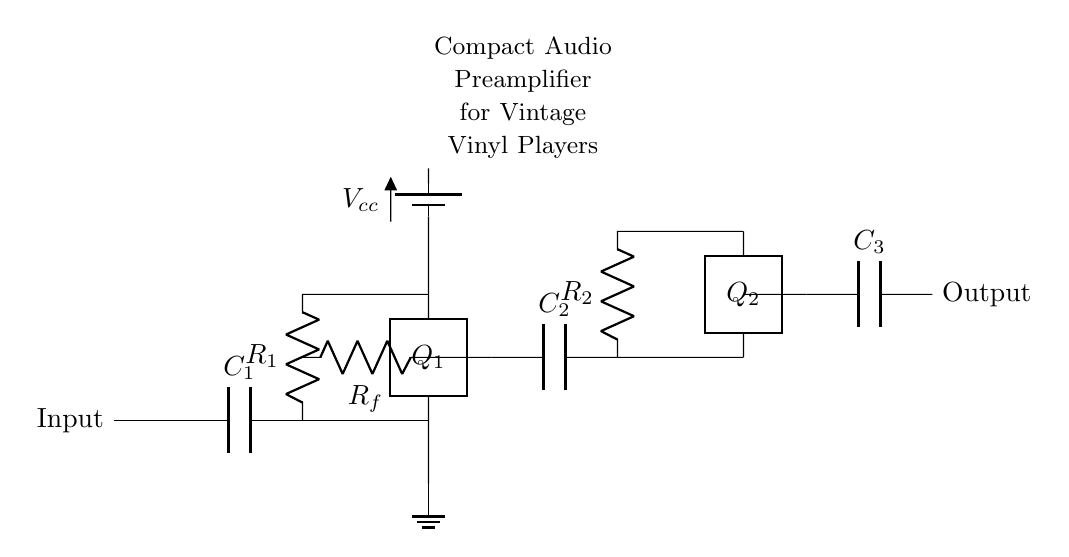What is the input component in this circuit? The input component is a capacitor, labeled as C1. It functions to couple the audio signal from the vinyl record player into the circuit while blocking any DC components.
Answer: C1 What type of transistors are used in this circuit? The circuit utilizes two bipolar junction transistors, indicated as Q1 and Q2, which amplify the audio signal.
Answer: Bipolar junction transistors How are the feedback and the input connected in the first stage? The feedback resistor Rf connects from the output side of the first transistor Q1 back to the input side, specifically between point (5,1) and (3,1), thereby providing negative feedback to stabilize the gain of the amplifier.
Answer: Through a feedback resistor What is the total number of capacitors in this circuit? Three capacitors are present in the circuit, C1 at the input, C2 in the second stage, and C3 at the output.
Answer: Three What is the purpose of the Rf component in this circuit? The resistor Rf is used to provide feedback to the first transistor Q1, which helps control the gain of the amplifier and stabilize the circuit operation by reducing distortion.
Answer: Control gain What voltage does the power supply provide? The power supply, labeled Vcc, provides a voltage that powers the circuit and is located at the battery section above transistor Q1, which usually needs to be set according to the specifications of the transistors used.
Answer: Vcc (not specified in value) How many stages of amplification are present in this preamplifier circuit? The circuit has two stages of amplification, with Q1 and Q2 representing the first and second stages respectively, allowing for increased gain of the audio signal.
Answer: Two stages 